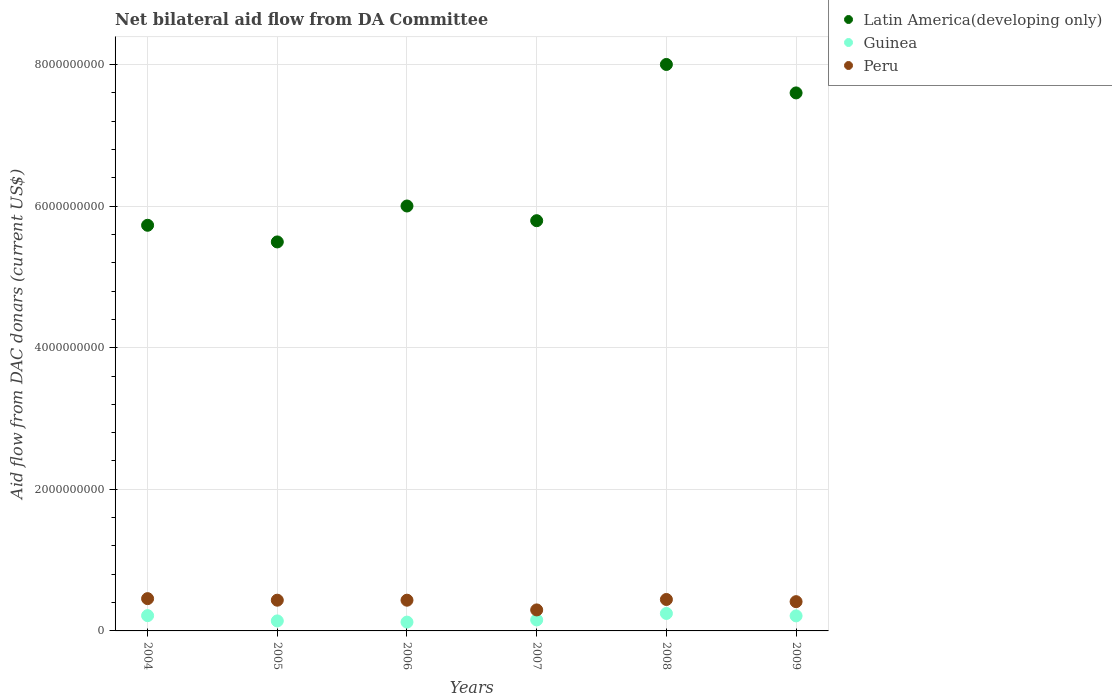How many different coloured dotlines are there?
Your answer should be compact. 3. What is the aid flow in in Latin America(developing only) in 2004?
Your answer should be very brief. 5.73e+09. Across all years, what is the maximum aid flow in in Peru?
Keep it short and to the point. 4.56e+08. Across all years, what is the minimum aid flow in in Peru?
Your response must be concise. 2.97e+08. What is the total aid flow in in Peru in the graph?
Offer a terse response. 2.48e+09. What is the difference between the aid flow in in Latin America(developing only) in 2004 and that in 2005?
Offer a very short reply. 2.35e+08. What is the difference between the aid flow in in Guinea in 2006 and the aid flow in in Peru in 2005?
Provide a short and direct response. -3.10e+08. What is the average aid flow in in Guinea per year?
Make the answer very short. 1.83e+08. In the year 2006, what is the difference between the aid flow in in Peru and aid flow in in Guinea?
Offer a very short reply. 3.09e+08. In how many years, is the aid flow in in Peru greater than 6800000000 US$?
Offer a terse response. 0. What is the ratio of the aid flow in in Guinea in 2005 to that in 2009?
Your response must be concise. 0.67. What is the difference between the highest and the second highest aid flow in in Peru?
Provide a short and direct response. 1.19e+07. What is the difference between the highest and the lowest aid flow in in Guinea?
Your answer should be compact. 1.22e+08. Does the aid flow in in Guinea monotonically increase over the years?
Provide a succinct answer. No. How many years are there in the graph?
Provide a succinct answer. 6. What is the difference between two consecutive major ticks on the Y-axis?
Offer a very short reply. 2.00e+09. Are the values on the major ticks of Y-axis written in scientific E-notation?
Your response must be concise. No. Does the graph contain any zero values?
Provide a succinct answer. No. What is the title of the graph?
Offer a terse response. Net bilateral aid flow from DA Committee. Does "Small states" appear as one of the legend labels in the graph?
Your answer should be compact. No. What is the label or title of the Y-axis?
Your answer should be compact. Aid flow from DAC donars (current US$). What is the Aid flow from DAC donars (current US$) of Latin America(developing only) in 2004?
Make the answer very short. 5.73e+09. What is the Aid flow from DAC donars (current US$) in Guinea in 2004?
Ensure brevity in your answer.  2.16e+08. What is the Aid flow from DAC donars (current US$) in Peru in 2004?
Ensure brevity in your answer.  4.56e+08. What is the Aid flow from DAC donars (current US$) in Latin America(developing only) in 2005?
Give a very brief answer. 5.49e+09. What is the Aid flow from DAC donars (current US$) of Guinea in 2005?
Your answer should be very brief. 1.41e+08. What is the Aid flow from DAC donars (current US$) in Peru in 2005?
Provide a succinct answer. 4.34e+08. What is the Aid flow from DAC donars (current US$) of Latin America(developing only) in 2006?
Offer a very short reply. 6.00e+09. What is the Aid flow from DAC donars (current US$) of Guinea in 2006?
Provide a succinct answer. 1.24e+08. What is the Aid flow from DAC donars (current US$) of Peru in 2006?
Offer a very short reply. 4.34e+08. What is the Aid flow from DAC donars (current US$) of Latin America(developing only) in 2007?
Make the answer very short. 5.79e+09. What is the Aid flow from DAC donars (current US$) in Guinea in 2007?
Ensure brevity in your answer.  1.56e+08. What is the Aid flow from DAC donars (current US$) in Peru in 2007?
Your answer should be very brief. 2.97e+08. What is the Aid flow from DAC donars (current US$) of Latin America(developing only) in 2008?
Your answer should be very brief. 8.00e+09. What is the Aid flow from DAC donars (current US$) in Guinea in 2008?
Your answer should be compact. 2.47e+08. What is the Aid flow from DAC donars (current US$) of Peru in 2008?
Your response must be concise. 4.44e+08. What is the Aid flow from DAC donars (current US$) of Latin America(developing only) in 2009?
Provide a short and direct response. 7.60e+09. What is the Aid flow from DAC donars (current US$) of Guinea in 2009?
Give a very brief answer. 2.12e+08. What is the Aid flow from DAC donars (current US$) in Peru in 2009?
Provide a short and direct response. 4.13e+08. Across all years, what is the maximum Aid flow from DAC donars (current US$) of Latin America(developing only)?
Ensure brevity in your answer.  8.00e+09. Across all years, what is the maximum Aid flow from DAC donars (current US$) in Guinea?
Ensure brevity in your answer.  2.47e+08. Across all years, what is the maximum Aid flow from DAC donars (current US$) of Peru?
Make the answer very short. 4.56e+08. Across all years, what is the minimum Aid flow from DAC donars (current US$) in Latin America(developing only)?
Your response must be concise. 5.49e+09. Across all years, what is the minimum Aid flow from DAC donars (current US$) in Guinea?
Your response must be concise. 1.24e+08. Across all years, what is the minimum Aid flow from DAC donars (current US$) in Peru?
Provide a succinct answer. 2.97e+08. What is the total Aid flow from DAC donars (current US$) of Latin America(developing only) in the graph?
Offer a very short reply. 3.86e+1. What is the total Aid flow from DAC donars (current US$) in Guinea in the graph?
Provide a succinct answer. 1.10e+09. What is the total Aid flow from DAC donars (current US$) of Peru in the graph?
Keep it short and to the point. 2.48e+09. What is the difference between the Aid flow from DAC donars (current US$) of Latin America(developing only) in 2004 and that in 2005?
Make the answer very short. 2.35e+08. What is the difference between the Aid flow from DAC donars (current US$) of Guinea in 2004 and that in 2005?
Offer a terse response. 7.46e+07. What is the difference between the Aid flow from DAC donars (current US$) of Peru in 2004 and that in 2005?
Your answer should be compact. 2.20e+07. What is the difference between the Aid flow from DAC donars (current US$) in Latin America(developing only) in 2004 and that in 2006?
Make the answer very short. -2.72e+08. What is the difference between the Aid flow from DAC donars (current US$) of Guinea in 2004 and that in 2006?
Ensure brevity in your answer.  9.15e+07. What is the difference between the Aid flow from DAC donars (current US$) of Peru in 2004 and that in 2006?
Your answer should be compact. 2.21e+07. What is the difference between the Aid flow from DAC donars (current US$) in Latin America(developing only) in 2004 and that in 2007?
Ensure brevity in your answer.  -6.46e+07. What is the difference between the Aid flow from DAC donars (current US$) in Guinea in 2004 and that in 2007?
Make the answer very short. 6.04e+07. What is the difference between the Aid flow from DAC donars (current US$) in Peru in 2004 and that in 2007?
Your response must be concise. 1.59e+08. What is the difference between the Aid flow from DAC donars (current US$) of Latin America(developing only) in 2004 and that in 2008?
Your answer should be compact. -2.27e+09. What is the difference between the Aid flow from DAC donars (current US$) in Guinea in 2004 and that in 2008?
Your response must be concise. -3.08e+07. What is the difference between the Aid flow from DAC donars (current US$) of Peru in 2004 and that in 2008?
Provide a succinct answer. 1.19e+07. What is the difference between the Aid flow from DAC donars (current US$) in Latin America(developing only) in 2004 and that in 2009?
Keep it short and to the point. -1.87e+09. What is the difference between the Aid flow from DAC donars (current US$) of Guinea in 2004 and that in 2009?
Your response must be concise. 3.46e+06. What is the difference between the Aid flow from DAC donars (current US$) of Peru in 2004 and that in 2009?
Make the answer very short. 4.28e+07. What is the difference between the Aid flow from DAC donars (current US$) of Latin America(developing only) in 2005 and that in 2006?
Offer a very short reply. -5.08e+08. What is the difference between the Aid flow from DAC donars (current US$) of Guinea in 2005 and that in 2006?
Your answer should be very brief. 1.69e+07. What is the difference between the Aid flow from DAC donars (current US$) of Peru in 2005 and that in 2006?
Keep it short and to the point. 1.40e+05. What is the difference between the Aid flow from DAC donars (current US$) of Latin America(developing only) in 2005 and that in 2007?
Make the answer very short. -3.00e+08. What is the difference between the Aid flow from DAC donars (current US$) in Guinea in 2005 and that in 2007?
Your answer should be compact. -1.42e+07. What is the difference between the Aid flow from DAC donars (current US$) of Peru in 2005 and that in 2007?
Your response must be concise. 1.37e+08. What is the difference between the Aid flow from DAC donars (current US$) in Latin America(developing only) in 2005 and that in 2008?
Offer a terse response. -2.51e+09. What is the difference between the Aid flow from DAC donars (current US$) in Guinea in 2005 and that in 2008?
Keep it short and to the point. -1.05e+08. What is the difference between the Aid flow from DAC donars (current US$) of Peru in 2005 and that in 2008?
Ensure brevity in your answer.  -1.01e+07. What is the difference between the Aid flow from DAC donars (current US$) of Latin America(developing only) in 2005 and that in 2009?
Offer a terse response. -2.10e+09. What is the difference between the Aid flow from DAC donars (current US$) in Guinea in 2005 and that in 2009?
Offer a terse response. -7.11e+07. What is the difference between the Aid flow from DAC donars (current US$) in Peru in 2005 and that in 2009?
Offer a terse response. 2.08e+07. What is the difference between the Aid flow from DAC donars (current US$) in Latin America(developing only) in 2006 and that in 2007?
Give a very brief answer. 2.08e+08. What is the difference between the Aid flow from DAC donars (current US$) of Guinea in 2006 and that in 2007?
Your answer should be compact. -3.11e+07. What is the difference between the Aid flow from DAC donars (current US$) in Peru in 2006 and that in 2007?
Provide a succinct answer. 1.37e+08. What is the difference between the Aid flow from DAC donars (current US$) in Latin America(developing only) in 2006 and that in 2008?
Your response must be concise. -2.00e+09. What is the difference between the Aid flow from DAC donars (current US$) in Guinea in 2006 and that in 2008?
Your answer should be very brief. -1.22e+08. What is the difference between the Aid flow from DAC donars (current US$) of Peru in 2006 and that in 2008?
Offer a very short reply. -1.02e+07. What is the difference between the Aid flow from DAC donars (current US$) of Latin America(developing only) in 2006 and that in 2009?
Provide a short and direct response. -1.60e+09. What is the difference between the Aid flow from DAC donars (current US$) in Guinea in 2006 and that in 2009?
Make the answer very short. -8.80e+07. What is the difference between the Aid flow from DAC donars (current US$) of Peru in 2006 and that in 2009?
Keep it short and to the point. 2.06e+07. What is the difference between the Aid flow from DAC donars (current US$) of Latin America(developing only) in 2007 and that in 2008?
Your answer should be compact. -2.21e+09. What is the difference between the Aid flow from DAC donars (current US$) of Guinea in 2007 and that in 2008?
Your answer should be compact. -9.12e+07. What is the difference between the Aid flow from DAC donars (current US$) in Peru in 2007 and that in 2008?
Your response must be concise. -1.47e+08. What is the difference between the Aid flow from DAC donars (current US$) in Latin America(developing only) in 2007 and that in 2009?
Your response must be concise. -1.80e+09. What is the difference between the Aid flow from DAC donars (current US$) of Guinea in 2007 and that in 2009?
Offer a terse response. -5.70e+07. What is the difference between the Aid flow from DAC donars (current US$) of Peru in 2007 and that in 2009?
Offer a very short reply. -1.17e+08. What is the difference between the Aid flow from DAC donars (current US$) of Latin America(developing only) in 2008 and that in 2009?
Give a very brief answer. 4.02e+08. What is the difference between the Aid flow from DAC donars (current US$) of Guinea in 2008 and that in 2009?
Offer a terse response. 3.42e+07. What is the difference between the Aid flow from DAC donars (current US$) of Peru in 2008 and that in 2009?
Provide a succinct answer. 3.08e+07. What is the difference between the Aid flow from DAC donars (current US$) of Latin America(developing only) in 2004 and the Aid flow from DAC donars (current US$) of Guinea in 2005?
Provide a succinct answer. 5.59e+09. What is the difference between the Aid flow from DAC donars (current US$) of Latin America(developing only) in 2004 and the Aid flow from DAC donars (current US$) of Peru in 2005?
Offer a very short reply. 5.30e+09. What is the difference between the Aid flow from DAC donars (current US$) of Guinea in 2004 and the Aid flow from DAC donars (current US$) of Peru in 2005?
Offer a terse response. -2.18e+08. What is the difference between the Aid flow from DAC donars (current US$) of Latin America(developing only) in 2004 and the Aid flow from DAC donars (current US$) of Guinea in 2006?
Provide a short and direct response. 5.60e+09. What is the difference between the Aid flow from DAC donars (current US$) in Latin America(developing only) in 2004 and the Aid flow from DAC donars (current US$) in Peru in 2006?
Your response must be concise. 5.30e+09. What is the difference between the Aid flow from DAC donars (current US$) of Guinea in 2004 and the Aid flow from DAC donars (current US$) of Peru in 2006?
Make the answer very short. -2.18e+08. What is the difference between the Aid flow from DAC donars (current US$) of Latin America(developing only) in 2004 and the Aid flow from DAC donars (current US$) of Guinea in 2007?
Offer a terse response. 5.57e+09. What is the difference between the Aid flow from DAC donars (current US$) of Latin America(developing only) in 2004 and the Aid flow from DAC donars (current US$) of Peru in 2007?
Provide a short and direct response. 5.43e+09. What is the difference between the Aid flow from DAC donars (current US$) in Guinea in 2004 and the Aid flow from DAC donars (current US$) in Peru in 2007?
Keep it short and to the point. -8.07e+07. What is the difference between the Aid flow from DAC donars (current US$) of Latin America(developing only) in 2004 and the Aid flow from DAC donars (current US$) of Guinea in 2008?
Keep it short and to the point. 5.48e+09. What is the difference between the Aid flow from DAC donars (current US$) of Latin America(developing only) in 2004 and the Aid flow from DAC donars (current US$) of Peru in 2008?
Offer a very short reply. 5.29e+09. What is the difference between the Aid flow from DAC donars (current US$) in Guinea in 2004 and the Aid flow from DAC donars (current US$) in Peru in 2008?
Offer a very short reply. -2.28e+08. What is the difference between the Aid flow from DAC donars (current US$) in Latin America(developing only) in 2004 and the Aid flow from DAC donars (current US$) in Guinea in 2009?
Provide a short and direct response. 5.52e+09. What is the difference between the Aid flow from DAC donars (current US$) of Latin America(developing only) in 2004 and the Aid flow from DAC donars (current US$) of Peru in 2009?
Your answer should be very brief. 5.32e+09. What is the difference between the Aid flow from DAC donars (current US$) in Guinea in 2004 and the Aid flow from DAC donars (current US$) in Peru in 2009?
Ensure brevity in your answer.  -1.97e+08. What is the difference between the Aid flow from DAC donars (current US$) of Latin America(developing only) in 2005 and the Aid flow from DAC donars (current US$) of Guinea in 2006?
Ensure brevity in your answer.  5.37e+09. What is the difference between the Aid flow from DAC donars (current US$) of Latin America(developing only) in 2005 and the Aid flow from DAC donars (current US$) of Peru in 2006?
Offer a very short reply. 5.06e+09. What is the difference between the Aid flow from DAC donars (current US$) of Guinea in 2005 and the Aid flow from DAC donars (current US$) of Peru in 2006?
Provide a short and direct response. -2.93e+08. What is the difference between the Aid flow from DAC donars (current US$) of Latin America(developing only) in 2005 and the Aid flow from DAC donars (current US$) of Guinea in 2007?
Provide a short and direct response. 5.34e+09. What is the difference between the Aid flow from DAC donars (current US$) in Latin America(developing only) in 2005 and the Aid flow from DAC donars (current US$) in Peru in 2007?
Provide a short and direct response. 5.20e+09. What is the difference between the Aid flow from DAC donars (current US$) of Guinea in 2005 and the Aid flow from DAC donars (current US$) of Peru in 2007?
Offer a terse response. -1.55e+08. What is the difference between the Aid flow from DAC donars (current US$) of Latin America(developing only) in 2005 and the Aid flow from DAC donars (current US$) of Guinea in 2008?
Offer a terse response. 5.25e+09. What is the difference between the Aid flow from DAC donars (current US$) of Latin America(developing only) in 2005 and the Aid flow from DAC donars (current US$) of Peru in 2008?
Make the answer very short. 5.05e+09. What is the difference between the Aid flow from DAC donars (current US$) in Guinea in 2005 and the Aid flow from DAC donars (current US$) in Peru in 2008?
Provide a succinct answer. -3.03e+08. What is the difference between the Aid flow from DAC donars (current US$) of Latin America(developing only) in 2005 and the Aid flow from DAC donars (current US$) of Guinea in 2009?
Provide a short and direct response. 5.28e+09. What is the difference between the Aid flow from DAC donars (current US$) in Latin America(developing only) in 2005 and the Aid flow from DAC donars (current US$) in Peru in 2009?
Ensure brevity in your answer.  5.08e+09. What is the difference between the Aid flow from DAC donars (current US$) of Guinea in 2005 and the Aid flow from DAC donars (current US$) of Peru in 2009?
Give a very brief answer. -2.72e+08. What is the difference between the Aid flow from DAC donars (current US$) of Latin America(developing only) in 2006 and the Aid flow from DAC donars (current US$) of Guinea in 2007?
Your answer should be very brief. 5.85e+09. What is the difference between the Aid flow from DAC donars (current US$) in Latin America(developing only) in 2006 and the Aid flow from DAC donars (current US$) in Peru in 2007?
Offer a terse response. 5.70e+09. What is the difference between the Aid flow from DAC donars (current US$) of Guinea in 2006 and the Aid flow from DAC donars (current US$) of Peru in 2007?
Make the answer very short. -1.72e+08. What is the difference between the Aid flow from DAC donars (current US$) of Latin America(developing only) in 2006 and the Aid flow from DAC donars (current US$) of Guinea in 2008?
Your answer should be compact. 5.75e+09. What is the difference between the Aid flow from DAC donars (current US$) in Latin America(developing only) in 2006 and the Aid flow from DAC donars (current US$) in Peru in 2008?
Provide a succinct answer. 5.56e+09. What is the difference between the Aid flow from DAC donars (current US$) in Guinea in 2006 and the Aid flow from DAC donars (current US$) in Peru in 2008?
Your answer should be very brief. -3.20e+08. What is the difference between the Aid flow from DAC donars (current US$) in Latin America(developing only) in 2006 and the Aid flow from DAC donars (current US$) in Guinea in 2009?
Provide a short and direct response. 5.79e+09. What is the difference between the Aid flow from DAC donars (current US$) of Latin America(developing only) in 2006 and the Aid flow from DAC donars (current US$) of Peru in 2009?
Offer a very short reply. 5.59e+09. What is the difference between the Aid flow from DAC donars (current US$) in Guinea in 2006 and the Aid flow from DAC donars (current US$) in Peru in 2009?
Your response must be concise. -2.89e+08. What is the difference between the Aid flow from DAC donars (current US$) of Latin America(developing only) in 2007 and the Aid flow from DAC donars (current US$) of Guinea in 2008?
Your answer should be very brief. 5.55e+09. What is the difference between the Aid flow from DAC donars (current US$) in Latin America(developing only) in 2007 and the Aid flow from DAC donars (current US$) in Peru in 2008?
Offer a very short reply. 5.35e+09. What is the difference between the Aid flow from DAC donars (current US$) in Guinea in 2007 and the Aid flow from DAC donars (current US$) in Peru in 2008?
Provide a short and direct response. -2.89e+08. What is the difference between the Aid flow from DAC donars (current US$) in Latin America(developing only) in 2007 and the Aid flow from DAC donars (current US$) in Guinea in 2009?
Offer a very short reply. 5.58e+09. What is the difference between the Aid flow from DAC donars (current US$) of Latin America(developing only) in 2007 and the Aid flow from DAC donars (current US$) of Peru in 2009?
Make the answer very short. 5.38e+09. What is the difference between the Aid flow from DAC donars (current US$) of Guinea in 2007 and the Aid flow from DAC donars (current US$) of Peru in 2009?
Provide a short and direct response. -2.58e+08. What is the difference between the Aid flow from DAC donars (current US$) of Latin America(developing only) in 2008 and the Aid flow from DAC donars (current US$) of Guinea in 2009?
Ensure brevity in your answer.  7.79e+09. What is the difference between the Aid flow from DAC donars (current US$) in Latin America(developing only) in 2008 and the Aid flow from DAC donars (current US$) in Peru in 2009?
Give a very brief answer. 7.59e+09. What is the difference between the Aid flow from DAC donars (current US$) of Guinea in 2008 and the Aid flow from DAC donars (current US$) of Peru in 2009?
Give a very brief answer. -1.67e+08. What is the average Aid flow from DAC donars (current US$) in Latin America(developing only) per year?
Ensure brevity in your answer.  6.44e+09. What is the average Aid flow from DAC donars (current US$) in Guinea per year?
Provide a succinct answer. 1.83e+08. What is the average Aid flow from DAC donars (current US$) in Peru per year?
Provide a succinct answer. 4.13e+08. In the year 2004, what is the difference between the Aid flow from DAC donars (current US$) of Latin America(developing only) and Aid flow from DAC donars (current US$) of Guinea?
Provide a succinct answer. 5.51e+09. In the year 2004, what is the difference between the Aid flow from DAC donars (current US$) in Latin America(developing only) and Aid flow from DAC donars (current US$) in Peru?
Provide a short and direct response. 5.27e+09. In the year 2004, what is the difference between the Aid flow from DAC donars (current US$) of Guinea and Aid flow from DAC donars (current US$) of Peru?
Provide a short and direct response. -2.40e+08. In the year 2005, what is the difference between the Aid flow from DAC donars (current US$) in Latin America(developing only) and Aid flow from DAC donars (current US$) in Guinea?
Give a very brief answer. 5.35e+09. In the year 2005, what is the difference between the Aid flow from DAC donars (current US$) in Latin America(developing only) and Aid flow from DAC donars (current US$) in Peru?
Ensure brevity in your answer.  5.06e+09. In the year 2005, what is the difference between the Aid flow from DAC donars (current US$) of Guinea and Aid flow from DAC donars (current US$) of Peru?
Offer a very short reply. -2.93e+08. In the year 2006, what is the difference between the Aid flow from DAC donars (current US$) of Latin America(developing only) and Aid flow from DAC donars (current US$) of Guinea?
Offer a very short reply. 5.88e+09. In the year 2006, what is the difference between the Aid flow from DAC donars (current US$) in Latin America(developing only) and Aid flow from DAC donars (current US$) in Peru?
Keep it short and to the point. 5.57e+09. In the year 2006, what is the difference between the Aid flow from DAC donars (current US$) of Guinea and Aid flow from DAC donars (current US$) of Peru?
Your answer should be very brief. -3.09e+08. In the year 2007, what is the difference between the Aid flow from DAC donars (current US$) of Latin America(developing only) and Aid flow from DAC donars (current US$) of Guinea?
Your response must be concise. 5.64e+09. In the year 2007, what is the difference between the Aid flow from DAC donars (current US$) of Latin America(developing only) and Aid flow from DAC donars (current US$) of Peru?
Offer a terse response. 5.50e+09. In the year 2007, what is the difference between the Aid flow from DAC donars (current US$) in Guinea and Aid flow from DAC donars (current US$) in Peru?
Your response must be concise. -1.41e+08. In the year 2008, what is the difference between the Aid flow from DAC donars (current US$) of Latin America(developing only) and Aid flow from DAC donars (current US$) of Guinea?
Your response must be concise. 7.75e+09. In the year 2008, what is the difference between the Aid flow from DAC donars (current US$) in Latin America(developing only) and Aid flow from DAC donars (current US$) in Peru?
Your answer should be very brief. 7.56e+09. In the year 2008, what is the difference between the Aid flow from DAC donars (current US$) of Guinea and Aid flow from DAC donars (current US$) of Peru?
Make the answer very short. -1.97e+08. In the year 2009, what is the difference between the Aid flow from DAC donars (current US$) in Latin America(developing only) and Aid flow from DAC donars (current US$) in Guinea?
Give a very brief answer. 7.39e+09. In the year 2009, what is the difference between the Aid flow from DAC donars (current US$) of Latin America(developing only) and Aid flow from DAC donars (current US$) of Peru?
Offer a terse response. 7.19e+09. In the year 2009, what is the difference between the Aid flow from DAC donars (current US$) of Guinea and Aid flow from DAC donars (current US$) of Peru?
Ensure brevity in your answer.  -2.01e+08. What is the ratio of the Aid flow from DAC donars (current US$) of Latin America(developing only) in 2004 to that in 2005?
Offer a very short reply. 1.04. What is the ratio of the Aid flow from DAC donars (current US$) of Guinea in 2004 to that in 2005?
Provide a short and direct response. 1.53. What is the ratio of the Aid flow from DAC donars (current US$) of Peru in 2004 to that in 2005?
Keep it short and to the point. 1.05. What is the ratio of the Aid flow from DAC donars (current US$) of Latin America(developing only) in 2004 to that in 2006?
Your response must be concise. 0.95. What is the ratio of the Aid flow from DAC donars (current US$) in Guinea in 2004 to that in 2006?
Ensure brevity in your answer.  1.74. What is the ratio of the Aid flow from DAC donars (current US$) in Peru in 2004 to that in 2006?
Ensure brevity in your answer.  1.05. What is the ratio of the Aid flow from DAC donars (current US$) of Latin America(developing only) in 2004 to that in 2007?
Keep it short and to the point. 0.99. What is the ratio of the Aid flow from DAC donars (current US$) in Guinea in 2004 to that in 2007?
Ensure brevity in your answer.  1.39. What is the ratio of the Aid flow from DAC donars (current US$) in Peru in 2004 to that in 2007?
Ensure brevity in your answer.  1.54. What is the ratio of the Aid flow from DAC donars (current US$) of Latin America(developing only) in 2004 to that in 2008?
Your response must be concise. 0.72. What is the ratio of the Aid flow from DAC donars (current US$) in Guinea in 2004 to that in 2008?
Keep it short and to the point. 0.88. What is the ratio of the Aid flow from DAC donars (current US$) of Peru in 2004 to that in 2008?
Ensure brevity in your answer.  1.03. What is the ratio of the Aid flow from DAC donars (current US$) in Latin America(developing only) in 2004 to that in 2009?
Provide a short and direct response. 0.75. What is the ratio of the Aid flow from DAC donars (current US$) of Guinea in 2004 to that in 2009?
Your answer should be very brief. 1.02. What is the ratio of the Aid flow from DAC donars (current US$) in Peru in 2004 to that in 2009?
Make the answer very short. 1.1. What is the ratio of the Aid flow from DAC donars (current US$) in Latin America(developing only) in 2005 to that in 2006?
Make the answer very short. 0.92. What is the ratio of the Aid flow from DAC donars (current US$) in Guinea in 2005 to that in 2006?
Give a very brief answer. 1.14. What is the ratio of the Aid flow from DAC donars (current US$) in Peru in 2005 to that in 2006?
Offer a terse response. 1. What is the ratio of the Aid flow from DAC donars (current US$) in Latin America(developing only) in 2005 to that in 2007?
Offer a terse response. 0.95. What is the ratio of the Aid flow from DAC donars (current US$) of Guinea in 2005 to that in 2007?
Your response must be concise. 0.91. What is the ratio of the Aid flow from DAC donars (current US$) in Peru in 2005 to that in 2007?
Your response must be concise. 1.46. What is the ratio of the Aid flow from DAC donars (current US$) in Latin America(developing only) in 2005 to that in 2008?
Provide a succinct answer. 0.69. What is the ratio of the Aid flow from DAC donars (current US$) of Guinea in 2005 to that in 2008?
Your response must be concise. 0.57. What is the ratio of the Aid flow from DAC donars (current US$) in Peru in 2005 to that in 2008?
Offer a terse response. 0.98. What is the ratio of the Aid flow from DAC donars (current US$) in Latin America(developing only) in 2005 to that in 2009?
Provide a short and direct response. 0.72. What is the ratio of the Aid flow from DAC donars (current US$) in Guinea in 2005 to that in 2009?
Ensure brevity in your answer.  0.67. What is the ratio of the Aid flow from DAC donars (current US$) in Peru in 2005 to that in 2009?
Ensure brevity in your answer.  1.05. What is the ratio of the Aid flow from DAC donars (current US$) in Latin America(developing only) in 2006 to that in 2007?
Give a very brief answer. 1.04. What is the ratio of the Aid flow from DAC donars (current US$) in Guinea in 2006 to that in 2007?
Your response must be concise. 0.8. What is the ratio of the Aid flow from DAC donars (current US$) of Peru in 2006 to that in 2007?
Offer a very short reply. 1.46. What is the ratio of the Aid flow from DAC donars (current US$) in Latin America(developing only) in 2006 to that in 2008?
Your answer should be compact. 0.75. What is the ratio of the Aid flow from DAC donars (current US$) in Guinea in 2006 to that in 2008?
Offer a very short reply. 0.5. What is the ratio of the Aid flow from DAC donars (current US$) in Latin America(developing only) in 2006 to that in 2009?
Give a very brief answer. 0.79. What is the ratio of the Aid flow from DAC donars (current US$) of Guinea in 2006 to that in 2009?
Keep it short and to the point. 0.59. What is the ratio of the Aid flow from DAC donars (current US$) in Latin America(developing only) in 2007 to that in 2008?
Make the answer very short. 0.72. What is the ratio of the Aid flow from DAC donars (current US$) of Guinea in 2007 to that in 2008?
Give a very brief answer. 0.63. What is the ratio of the Aid flow from DAC donars (current US$) of Peru in 2007 to that in 2008?
Your answer should be compact. 0.67. What is the ratio of the Aid flow from DAC donars (current US$) of Latin America(developing only) in 2007 to that in 2009?
Provide a succinct answer. 0.76. What is the ratio of the Aid flow from DAC donars (current US$) of Guinea in 2007 to that in 2009?
Provide a succinct answer. 0.73. What is the ratio of the Aid flow from DAC donars (current US$) of Peru in 2007 to that in 2009?
Offer a very short reply. 0.72. What is the ratio of the Aid flow from DAC donars (current US$) of Latin America(developing only) in 2008 to that in 2009?
Offer a terse response. 1.05. What is the ratio of the Aid flow from DAC donars (current US$) of Guinea in 2008 to that in 2009?
Your response must be concise. 1.16. What is the ratio of the Aid flow from DAC donars (current US$) of Peru in 2008 to that in 2009?
Your answer should be compact. 1.07. What is the difference between the highest and the second highest Aid flow from DAC donars (current US$) of Latin America(developing only)?
Provide a short and direct response. 4.02e+08. What is the difference between the highest and the second highest Aid flow from DAC donars (current US$) in Guinea?
Your answer should be very brief. 3.08e+07. What is the difference between the highest and the second highest Aid flow from DAC donars (current US$) in Peru?
Your answer should be very brief. 1.19e+07. What is the difference between the highest and the lowest Aid flow from DAC donars (current US$) in Latin America(developing only)?
Provide a succinct answer. 2.51e+09. What is the difference between the highest and the lowest Aid flow from DAC donars (current US$) of Guinea?
Keep it short and to the point. 1.22e+08. What is the difference between the highest and the lowest Aid flow from DAC donars (current US$) in Peru?
Provide a short and direct response. 1.59e+08. 